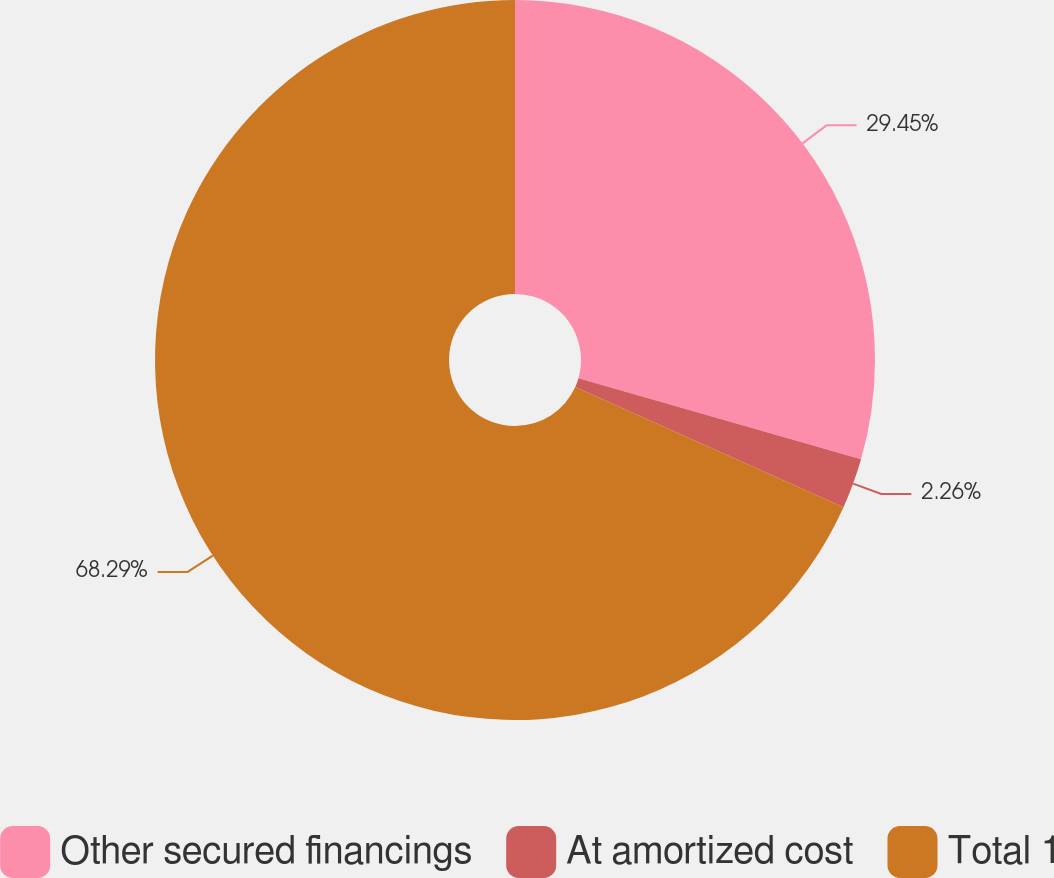Convert chart to OTSL. <chart><loc_0><loc_0><loc_500><loc_500><pie_chart><fcel>Other secured financings<fcel>At amortized cost<fcel>Total 1<nl><fcel>29.45%<fcel>2.26%<fcel>68.29%<nl></chart> 